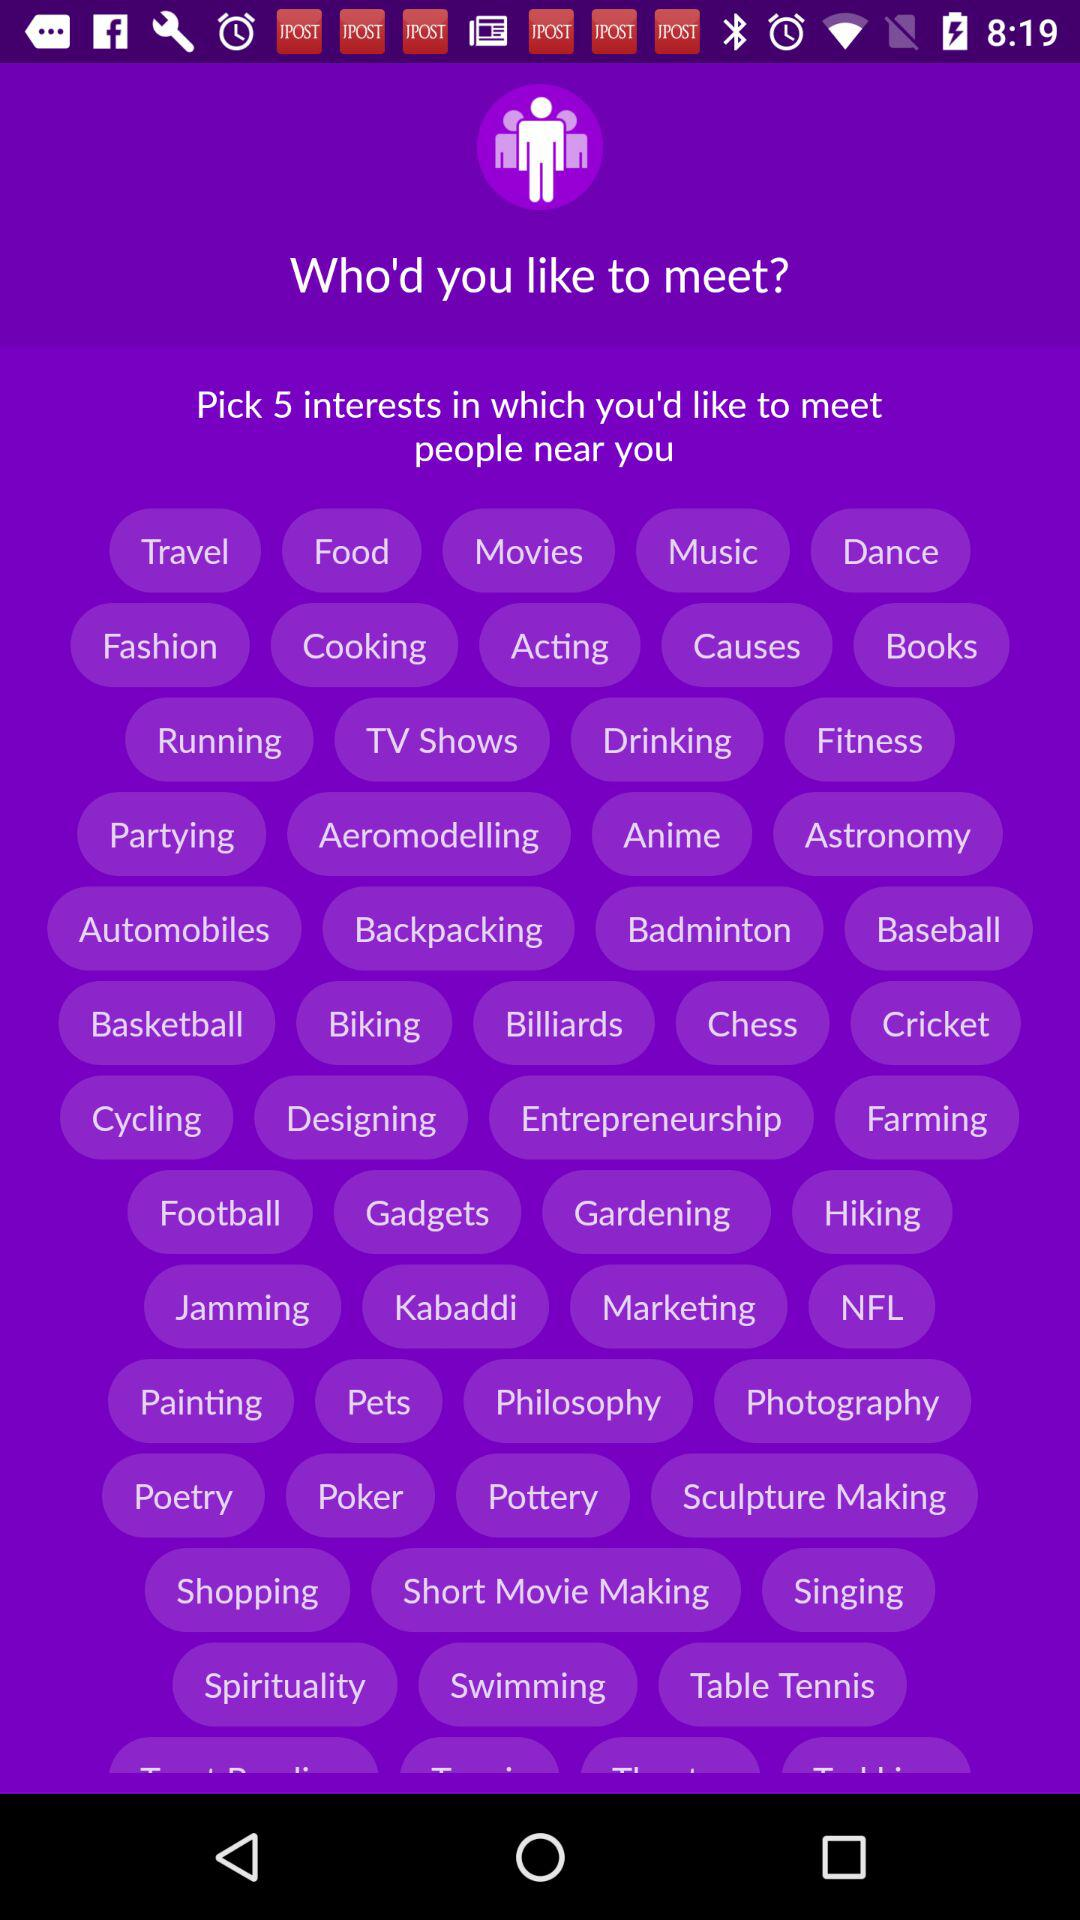How many interests can you pick to meet people near you? You can pick five interests. 